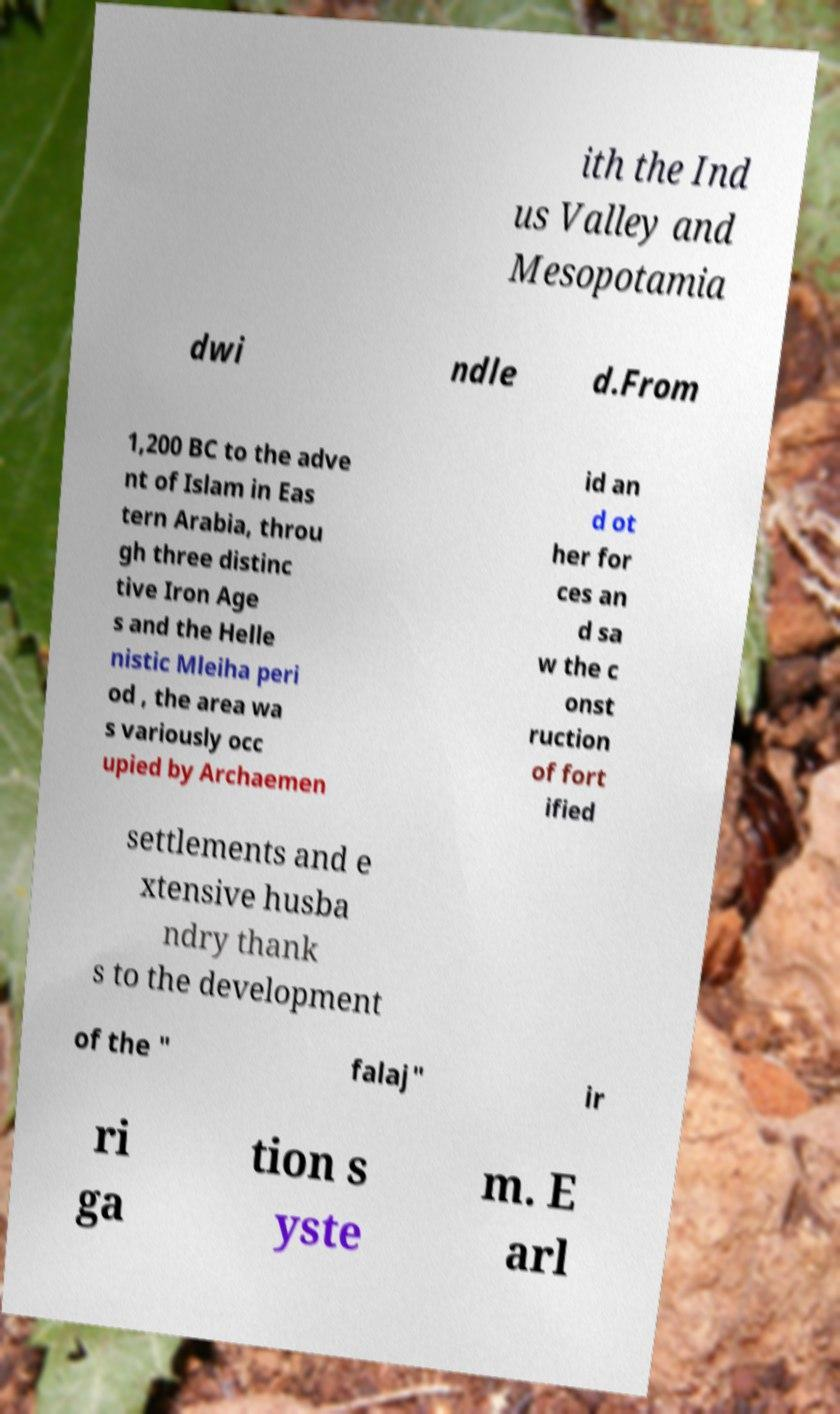Could you assist in decoding the text presented in this image and type it out clearly? ith the Ind us Valley and Mesopotamia dwi ndle d.From 1,200 BC to the adve nt of Islam in Eas tern Arabia, throu gh three distinc tive Iron Age s and the Helle nistic Mleiha peri od , the area wa s variously occ upied by Archaemen id an d ot her for ces an d sa w the c onst ruction of fort ified settlements and e xtensive husba ndry thank s to the development of the " falaj" ir ri ga tion s yste m. E arl 